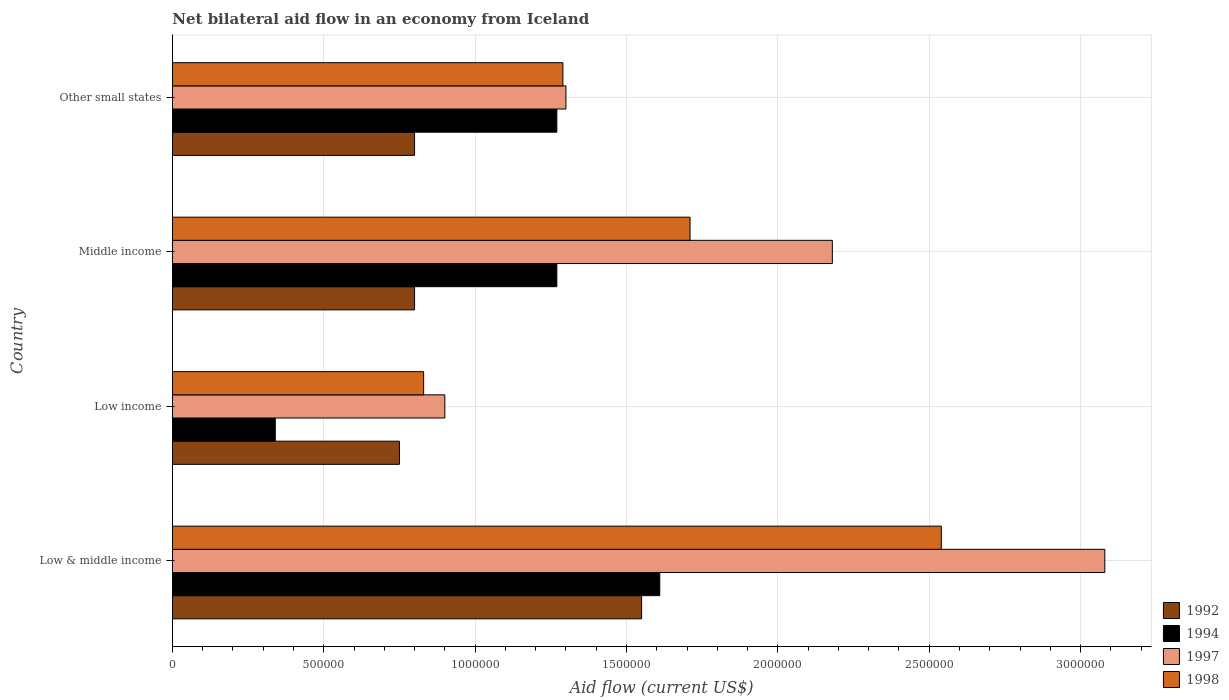How many groups of bars are there?
Make the answer very short. 4. What is the net bilateral aid flow in 1997 in Low & middle income?
Make the answer very short. 3.08e+06. Across all countries, what is the maximum net bilateral aid flow in 1992?
Offer a terse response. 1.55e+06. Across all countries, what is the minimum net bilateral aid flow in 1998?
Make the answer very short. 8.30e+05. What is the total net bilateral aid flow in 1998 in the graph?
Give a very brief answer. 6.37e+06. What is the difference between the net bilateral aid flow in 1997 in Low income and that in Middle income?
Give a very brief answer. -1.28e+06. What is the difference between the net bilateral aid flow in 1992 in Middle income and the net bilateral aid flow in 1994 in Low income?
Provide a short and direct response. 4.60e+05. What is the average net bilateral aid flow in 1998 per country?
Your answer should be very brief. 1.59e+06. What is the difference between the net bilateral aid flow in 1992 and net bilateral aid flow in 1998 in Low & middle income?
Keep it short and to the point. -9.90e+05. What is the ratio of the net bilateral aid flow in 1992 in Middle income to that in Other small states?
Make the answer very short. 1. Is the net bilateral aid flow in 1998 in Low income less than that in Other small states?
Your answer should be very brief. Yes. What is the difference between the highest and the second highest net bilateral aid flow in 1997?
Your answer should be very brief. 9.00e+05. What is the difference between the highest and the lowest net bilateral aid flow in 1994?
Your answer should be very brief. 1.27e+06. Is it the case that in every country, the sum of the net bilateral aid flow in 1992 and net bilateral aid flow in 1997 is greater than the sum of net bilateral aid flow in 1998 and net bilateral aid flow in 1994?
Keep it short and to the point. No. What does the 4th bar from the top in Low income represents?
Offer a terse response. 1992. What does the 2nd bar from the bottom in Middle income represents?
Provide a succinct answer. 1994. How many countries are there in the graph?
Make the answer very short. 4. What is the difference between two consecutive major ticks on the X-axis?
Make the answer very short. 5.00e+05. Are the values on the major ticks of X-axis written in scientific E-notation?
Offer a terse response. No. Does the graph contain any zero values?
Provide a short and direct response. No. Does the graph contain grids?
Your answer should be compact. Yes. Where does the legend appear in the graph?
Provide a short and direct response. Bottom right. How many legend labels are there?
Make the answer very short. 4. How are the legend labels stacked?
Your response must be concise. Vertical. What is the title of the graph?
Provide a succinct answer. Net bilateral aid flow in an economy from Iceland. Does "1995" appear as one of the legend labels in the graph?
Provide a short and direct response. No. What is the label or title of the X-axis?
Keep it short and to the point. Aid flow (current US$). What is the Aid flow (current US$) in 1992 in Low & middle income?
Ensure brevity in your answer.  1.55e+06. What is the Aid flow (current US$) of 1994 in Low & middle income?
Offer a terse response. 1.61e+06. What is the Aid flow (current US$) of 1997 in Low & middle income?
Provide a succinct answer. 3.08e+06. What is the Aid flow (current US$) of 1998 in Low & middle income?
Make the answer very short. 2.54e+06. What is the Aid flow (current US$) in 1992 in Low income?
Your response must be concise. 7.50e+05. What is the Aid flow (current US$) in 1997 in Low income?
Ensure brevity in your answer.  9.00e+05. What is the Aid flow (current US$) of 1998 in Low income?
Give a very brief answer. 8.30e+05. What is the Aid flow (current US$) in 1992 in Middle income?
Provide a short and direct response. 8.00e+05. What is the Aid flow (current US$) in 1994 in Middle income?
Your answer should be very brief. 1.27e+06. What is the Aid flow (current US$) in 1997 in Middle income?
Provide a short and direct response. 2.18e+06. What is the Aid flow (current US$) in 1998 in Middle income?
Give a very brief answer. 1.71e+06. What is the Aid flow (current US$) in 1994 in Other small states?
Ensure brevity in your answer.  1.27e+06. What is the Aid flow (current US$) in 1997 in Other small states?
Your answer should be compact. 1.30e+06. What is the Aid flow (current US$) of 1998 in Other small states?
Keep it short and to the point. 1.29e+06. Across all countries, what is the maximum Aid flow (current US$) of 1992?
Keep it short and to the point. 1.55e+06. Across all countries, what is the maximum Aid flow (current US$) of 1994?
Keep it short and to the point. 1.61e+06. Across all countries, what is the maximum Aid flow (current US$) in 1997?
Give a very brief answer. 3.08e+06. Across all countries, what is the maximum Aid flow (current US$) of 1998?
Keep it short and to the point. 2.54e+06. Across all countries, what is the minimum Aid flow (current US$) in 1992?
Ensure brevity in your answer.  7.50e+05. Across all countries, what is the minimum Aid flow (current US$) of 1998?
Keep it short and to the point. 8.30e+05. What is the total Aid flow (current US$) of 1992 in the graph?
Your answer should be very brief. 3.90e+06. What is the total Aid flow (current US$) in 1994 in the graph?
Offer a very short reply. 4.49e+06. What is the total Aid flow (current US$) of 1997 in the graph?
Make the answer very short. 7.46e+06. What is the total Aid flow (current US$) in 1998 in the graph?
Give a very brief answer. 6.37e+06. What is the difference between the Aid flow (current US$) of 1992 in Low & middle income and that in Low income?
Keep it short and to the point. 8.00e+05. What is the difference between the Aid flow (current US$) of 1994 in Low & middle income and that in Low income?
Ensure brevity in your answer.  1.27e+06. What is the difference between the Aid flow (current US$) of 1997 in Low & middle income and that in Low income?
Your answer should be very brief. 2.18e+06. What is the difference between the Aid flow (current US$) in 1998 in Low & middle income and that in Low income?
Make the answer very short. 1.71e+06. What is the difference between the Aid flow (current US$) in 1992 in Low & middle income and that in Middle income?
Offer a terse response. 7.50e+05. What is the difference between the Aid flow (current US$) in 1997 in Low & middle income and that in Middle income?
Ensure brevity in your answer.  9.00e+05. What is the difference between the Aid flow (current US$) in 1998 in Low & middle income and that in Middle income?
Provide a short and direct response. 8.30e+05. What is the difference between the Aid flow (current US$) in 1992 in Low & middle income and that in Other small states?
Ensure brevity in your answer.  7.50e+05. What is the difference between the Aid flow (current US$) of 1994 in Low & middle income and that in Other small states?
Your answer should be compact. 3.40e+05. What is the difference between the Aid flow (current US$) of 1997 in Low & middle income and that in Other small states?
Ensure brevity in your answer.  1.78e+06. What is the difference between the Aid flow (current US$) in 1998 in Low & middle income and that in Other small states?
Provide a succinct answer. 1.25e+06. What is the difference between the Aid flow (current US$) in 1994 in Low income and that in Middle income?
Provide a short and direct response. -9.30e+05. What is the difference between the Aid flow (current US$) in 1997 in Low income and that in Middle income?
Give a very brief answer. -1.28e+06. What is the difference between the Aid flow (current US$) of 1998 in Low income and that in Middle income?
Your answer should be very brief. -8.80e+05. What is the difference between the Aid flow (current US$) in 1992 in Low income and that in Other small states?
Make the answer very short. -5.00e+04. What is the difference between the Aid flow (current US$) in 1994 in Low income and that in Other small states?
Offer a terse response. -9.30e+05. What is the difference between the Aid flow (current US$) in 1997 in Low income and that in Other small states?
Your answer should be compact. -4.00e+05. What is the difference between the Aid flow (current US$) in 1998 in Low income and that in Other small states?
Your answer should be very brief. -4.60e+05. What is the difference between the Aid flow (current US$) in 1992 in Middle income and that in Other small states?
Keep it short and to the point. 0. What is the difference between the Aid flow (current US$) of 1997 in Middle income and that in Other small states?
Provide a succinct answer. 8.80e+05. What is the difference between the Aid flow (current US$) in 1998 in Middle income and that in Other small states?
Offer a terse response. 4.20e+05. What is the difference between the Aid flow (current US$) of 1992 in Low & middle income and the Aid flow (current US$) of 1994 in Low income?
Your answer should be very brief. 1.21e+06. What is the difference between the Aid flow (current US$) of 1992 in Low & middle income and the Aid flow (current US$) of 1997 in Low income?
Make the answer very short. 6.50e+05. What is the difference between the Aid flow (current US$) in 1992 in Low & middle income and the Aid flow (current US$) in 1998 in Low income?
Provide a succinct answer. 7.20e+05. What is the difference between the Aid flow (current US$) in 1994 in Low & middle income and the Aid flow (current US$) in 1997 in Low income?
Offer a very short reply. 7.10e+05. What is the difference between the Aid flow (current US$) of 1994 in Low & middle income and the Aid flow (current US$) of 1998 in Low income?
Offer a terse response. 7.80e+05. What is the difference between the Aid flow (current US$) of 1997 in Low & middle income and the Aid flow (current US$) of 1998 in Low income?
Offer a very short reply. 2.25e+06. What is the difference between the Aid flow (current US$) of 1992 in Low & middle income and the Aid flow (current US$) of 1994 in Middle income?
Make the answer very short. 2.80e+05. What is the difference between the Aid flow (current US$) of 1992 in Low & middle income and the Aid flow (current US$) of 1997 in Middle income?
Make the answer very short. -6.30e+05. What is the difference between the Aid flow (current US$) of 1992 in Low & middle income and the Aid flow (current US$) of 1998 in Middle income?
Your answer should be compact. -1.60e+05. What is the difference between the Aid flow (current US$) in 1994 in Low & middle income and the Aid flow (current US$) in 1997 in Middle income?
Keep it short and to the point. -5.70e+05. What is the difference between the Aid flow (current US$) of 1994 in Low & middle income and the Aid flow (current US$) of 1998 in Middle income?
Offer a terse response. -1.00e+05. What is the difference between the Aid flow (current US$) in 1997 in Low & middle income and the Aid flow (current US$) in 1998 in Middle income?
Give a very brief answer. 1.37e+06. What is the difference between the Aid flow (current US$) in 1992 in Low & middle income and the Aid flow (current US$) in 1994 in Other small states?
Offer a terse response. 2.80e+05. What is the difference between the Aid flow (current US$) of 1992 in Low & middle income and the Aid flow (current US$) of 1997 in Other small states?
Your response must be concise. 2.50e+05. What is the difference between the Aid flow (current US$) of 1994 in Low & middle income and the Aid flow (current US$) of 1998 in Other small states?
Your answer should be compact. 3.20e+05. What is the difference between the Aid flow (current US$) of 1997 in Low & middle income and the Aid flow (current US$) of 1998 in Other small states?
Give a very brief answer. 1.79e+06. What is the difference between the Aid flow (current US$) in 1992 in Low income and the Aid flow (current US$) in 1994 in Middle income?
Ensure brevity in your answer.  -5.20e+05. What is the difference between the Aid flow (current US$) in 1992 in Low income and the Aid flow (current US$) in 1997 in Middle income?
Provide a short and direct response. -1.43e+06. What is the difference between the Aid flow (current US$) in 1992 in Low income and the Aid flow (current US$) in 1998 in Middle income?
Provide a succinct answer. -9.60e+05. What is the difference between the Aid flow (current US$) in 1994 in Low income and the Aid flow (current US$) in 1997 in Middle income?
Provide a short and direct response. -1.84e+06. What is the difference between the Aid flow (current US$) in 1994 in Low income and the Aid flow (current US$) in 1998 in Middle income?
Give a very brief answer. -1.37e+06. What is the difference between the Aid flow (current US$) of 1997 in Low income and the Aid flow (current US$) of 1998 in Middle income?
Your answer should be very brief. -8.10e+05. What is the difference between the Aid flow (current US$) of 1992 in Low income and the Aid flow (current US$) of 1994 in Other small states?
Give a very brief answer. -5.20e+05. What is the difference between the Aid flow (current US$) in 1992 in Low income and the Aid flow (current US$) in 1997 in Other small states?
Provide a succinct answer. -5.50e+05. What is the difference between the Aid flow (current US$) of 1992 in Low income and the Aid flow (current US$) of 1998 in Other small states?
Make the answer very short. -5.40e+05. What is the difference between the Aid flow (current US$) in 1994 in Low income and the Aid flow (current US$) in 1997 in Other small states?
Your answer should be compact. -9.60e+05. What is the difference between the Aid flow (current US$) of 1994 in Low income and the Aid flow (current US$) of 1998 in Other small states?
Offer a terse response. -9.50e+05. What is the difference between the Aid flow (current US$) in 1997 in Low income and the Aid flow (current US$) in 1998 in Other small states?
Provide a succinct answer. -3.90e+05. What is the difference between the Aid flow (current US$) of 1992 in Middle income and the Aid flow (current US$) of 1994 in Other small states?
Offer a very short reply. -4.70e+05. What is the difference between the Aid flow (current US$) of 1992 in Middle income and the Aid flow (current US$) of 1997 in Other small states?
Your response must be concise. -5.00e+05. What is the difference between the Aid flow (current US$) in 1992 in Middle income and the Aid flow (current US$) in 1998 in Other small states?
Your response must be concise. -4.90e+05. What is the difference between the Aid flow (current US$) in 1994 in Middle income and the Aid flow (current US$) in 1998 in Other small states?
Keep it short and to the point. -2.00e+04. What is the difference between the Aid flow (current US$) in 1997 in Middle income and the Aid flow (current US$) in 1998 in Other small states?
Make the answer very short. 8.90e+05. What is the average Aid flow (current US$) in 1992 per country?
Keep it short and to the point. 9.75e+05. What is the average Aid flow (current US$) of 1994 per country?
Your response must be concise. 1.12e+06. What is the average Aid flow (current US$) in 1997 per country?
Provide a succinct answer. 1.86e+06. What is the average Aid flow (current US$) in 1998 per country?
Your answer should be very brief. 1.59e+06. What is the difference between the Aid flow (current US$) of 1992 and Aid flow (current US$) of 1994 in Low & middle income?
Make the answer very short. -6.00e+04. What is the difference between the Aid flow (current US$) in 1992 and Aid flow (current US$) in 1997 in Low & middle income?
Your answer should be very brief. -1.53e+06. What is the difference between the Aid flow (current US$) in 1992 and Aid flow (current US$) in 1998 in Low & middle income?
Provide a short and direct response. -9.90e+05. What is the difference between the Aid flow (current US$) in 1994 and Aid flow (current US$) in 1997 in Low & middle income?
Give a very brief answer. -1.47e+06. What is the difference between the Aid flow (current US$) in 1994 and Aid flow (current US$) in 1998 in Low & middle income?
Your response must be concise. -9.30e+05. What is the difference between the Aid flow (current US$) of 1997 and Aid flow (current US$) of 1998 in Low & middle income?
Make the answer very short. 5.40e+05. What is the difference between the Aid flow (current US$) in 1992 and Aid flow (current US$) in 1994 in Low income?
Provide a succinct answer. 4.10e+05. What is the difference between the Aid flow (current US$) in 1992 and Aid flow (current US$) in 1997 in Low income?
Make the answer very short. -1.50e+05. What is the difference between the Aid flow (current US$) of 1992 and Aid flow (current US$) of 1998 in Low income?
Provide a short and direct response. -8.00e+04. What is the difference between the Aid flow (current US$) of 1994 and Aid flow (current US$) of 1997 in Low income?
Ensure brevity in your answer.  -5.60e+05. What is the difference between the Aid flow (current US$) in 1994 and Aid flow (current US$) in 1998 in Low income?
Make the answer very short. -4.90e+05. What is the difference between the Aid flow (current US$) in 1997 and Aid flow (current US$) in 1998 in Low income?
Offer a very short reply. 7.00e+04. What is the difference between the Aid flow (current US$) in 1992 and Aid flow (current US$) in 1994 in Middle income?
Your answer should be very brief. -4.70e+05. What is the difference between the Aid flow (current US$) of 1992 and Aid flow (current US$) of 1997 in Middle income?
Provide a short and direct response. -1.38e+06. What is the difference between the Aid flow (current US$) in 1992 and Aid flow (current US$) in 1998 in Middle income?
Provide a short and direct response. -9.10e+05. What is the difference between the Aid flow (current US$) of 1994 and Aid flow (current US$) of 1997 in Middle income?
Give a very brief answer. -9.10e+05. What is the difference between the Aid flow (current US$) of 1994 and Aid flow (current US$) of 1998 in Middle income?
Provide a short and direct response. -4.40e+05. What is the difference between the Aid flow (current US$) of 1992 and Aid flow (current US$) of 1994 in Other small states?
Keep it short and to the point. -4.70e+05. What is the difference between the Aid flow (current US$) in 1992 and Aid flow (current US$) in 1997 in Other small states?
Provide a short and direct response. -5.00e+05. What is the difference between the Aid flow (current US$) of 1992 and Aid flow (current US$) of 1998 in Other small states?
Provide a short and direct response. -4.90e+05. What is the difference between the Aid flow (current US$) in 1994 and Aid flow (current US$) in 1998 in Other small states?
Provide a short and direct response. -2.00e+04. What is the ratio of the Aid flow (current US$) in 1992 in Low & middle income to that in Low income?
Keep it short and to the point. 2.07. What is the ratio of the Aid flow (current US$) in 1994 in Low & middle income to that in Low income?
Ensure brevity in your answer.  4.74. What is the ratio of the Aid flow (current US$) of 1997 in Low & middle income to that in Low income?
Provide a short and direct response. 3.42. What is the ratio of the Aid flow (current US$) of 1998 in Low & middle income to that in Low income?
Provide a succinct answer. 3.06. What is the ratio of the Aid flow (current US$) of 1992 in Low & middle income to that in Middle income?
Give a very brief answer. 1.94. What is the ratio of the Aid flow (current US$) in 1994 in Low & middle income to that in Middle income?
Your answer should be compact. 1.27. What is the ratio of the Aid flow (current US$) in 1997 in Low & middle income to that in Middle income?
Provide a short and direct response. 1.41. What is the ratio of the Aid flow (current US$) of 1998 in Low & middle income to that in Middle income?
Keep it short and to the point. 1.49. What is the ratio of the Aid flow (current US$) in 1992 in Low & middle income to that in Other small states?
Your answer should be compact. 1.94. What is the ratio of the Aid flow (current US$) of 1994 in Low & middle income to that in Other small states?
Give a very brief answer. 1.27. What is the ratio of the Aid flow (current US$) of 1997 in Low & middle income to that in Other small states?
Your answer should be very brief. 2.37. What is the ratio of the Aid flow (current US$) in 1998 in Low & middle income to that in Other small states?
Ensure brevity in your answer.  1.97. What is the ratio of the Aid flow (current US$) in 1992 in Low income to that in Middle income?
Your answer should be compact. 0.94. What is the ratio of the Aid flow (current US$) of 1994 in Low income to that in Middle income?
Provide a short and direct response. 0.27. What is the ratio of the Aid flow (current US$) in 1997 in Low income to that in Middle income?
Give a very brief answer. 0.41. What is the ratio of the Aid flow (current US$) in 1998 in Low income to that in Middle income?
Your answer should be very brief. 0.49. What is the ratio of the Aid flow (current US$) in 1992 in Low income to that in Other small states?
Make the answer very short. 0.94. What is the ratio of the Aid flow (current US$) in 1994 in Low income to that in Other small states?
Provide a succinct answer. 0.27. What is the ratio of the Aid flow (current US$) of 1997 in Low income to that in Other small states?
Your response must be concise. 0.69. What is the ratio of the Aid flow (current US$) in 1998 in Low income to that in Other small states?
Offer a very short reply. 0.64. What is the ratio of the Aid flow (current US$) of 1992 in Middle income to that in Other small states?
Offer a very short reply. 1. What is the ratio of the Aid flow (current US$) in 1997 in Middle income to that in Other small states?
Your answer should be compact. 1.68. What is the ratio of the Aid flow (current US$) in 1998 in Middle income to that in Other small states?
Give a very brief answer. 1.33. What is the difference between the highest and the second highest Aid flow (current US$) in 1992?
Give a very brief answer. 7.50e+05. What is the difference between the highest and the second highest Aid flow (current US$) of 1994?
Your response must be concise. 3.40e+05. What is the difference between the highest and the second highest Aid flow (current US$) of 1998?
Your answer should be very brief. 8.30e+05. What is the difference between the highest and the lowest Aid flow (current US$) of 1994?
Your response must be concise. 1.27e+06. What is the difference between the highest and the lowest Aid flow (current US$) of 1997?
Keep it short and to the point. 2.18e+06. What is the difference between the highest and the lowest Aid flow (current US$) in 1998?
Offer a very short reply. 1.71e+06. 